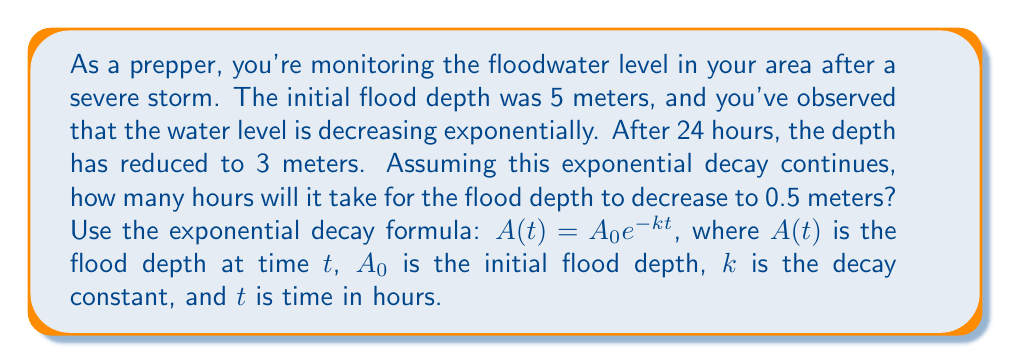Solve this math problem. Let's approach this step-by-step:

1) We're given the exponential decay formula: $A(t) = A_0 e^{-kt}$

2) We know:
   $A_0 = 5$ meters (initial depth)
   $A(24) = 3$ meters (depth after 24 hours)
   We need to find $t$ when $A(t) = 0.5$ meters

3) First, let's find the decay constant $k$ using the information at $t = 24$:
   $3 = 5e^{-24k}$

4) Dividing both sides by 5:
   $\frac{3}{5} = e^{-24k}$

5) Taking the natural log of both sides:
   $\ln(\frac{3}{5}) = -24k$

6) Solving for $k$:
   $k = -\frac{1}{24}\ln(\frac{3}{5}) \approx 0.0208$

7) Now that we have $k$, we can use the original formula to find $t$ when $A(t) = 0.5$:
   $0.5 = 5e^{-0.0208t}$

8) Dividing both sides by 5:
   $0.1 = e^{-0.0208t}$

9) Taking the natural log of both sides:
   $\ln(0.1) = -0.0208t$

10) Solving for $t$:
    $t = -\frac{\ln(0.1)}{0.0208} \approx 110.9$ hours
Answer: It will take approximately 111 hours (rounded to the nearest hour) for the flood depth to decrease to 0.5 meters. 